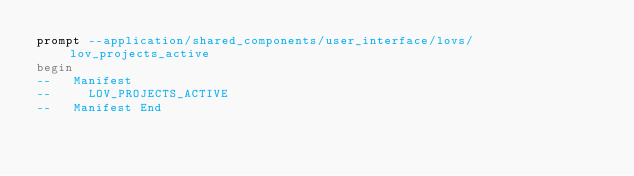Convert code to text. <code><loc_0><loc_0><loc_500><loc_500><_SQL_>prompt --application/shared_components/user_interface/lovs/lov_projects_active
begin
--   Manifest
--     LOV_PROJECTS_ACTIVE
--   Manifest End</code> 